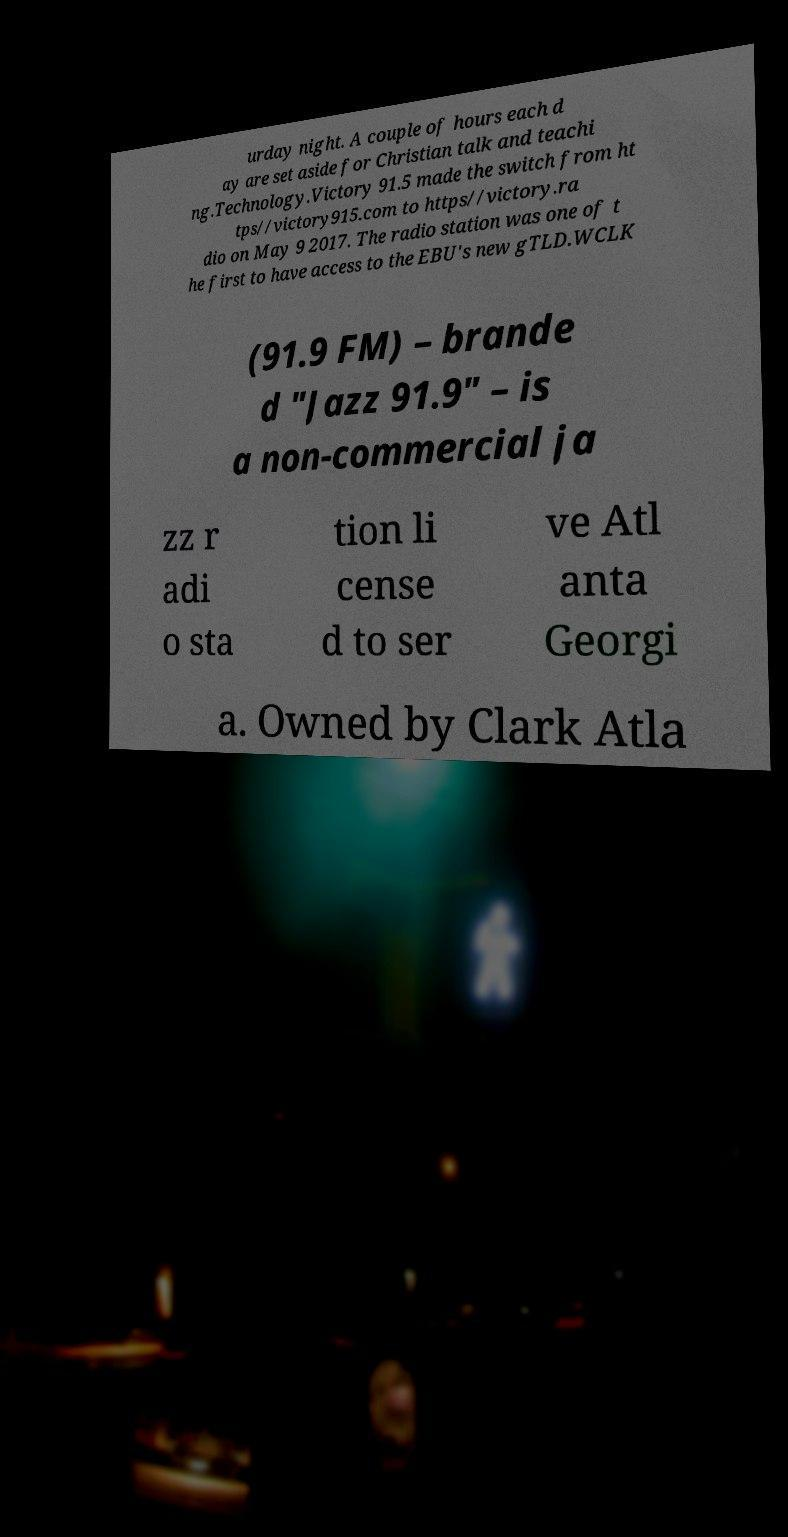Could you assist in decoding the text presented in this image and type it out clearly? urday night. A couple of hours each d ay are set aside for Christian talk and teachi ng.Technology.Victory 91.5 made the switch from ht tps//victory915.com to https//victory.ra dio on May 9 2017. The radio station was one of t he first to have access to the EBU's new gTLD.WCLK (91.9 FM) – brande d "Jazz 91.9" – is a non-commercial ja zz r adi o sta tion li cense d to ser ve Atl anta Georgi a. Owned by Clark Atla 